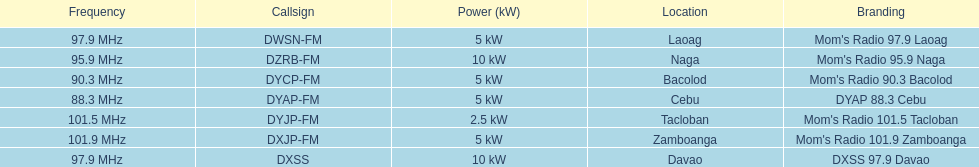How many kw was the radio in davao? 10 kW. 